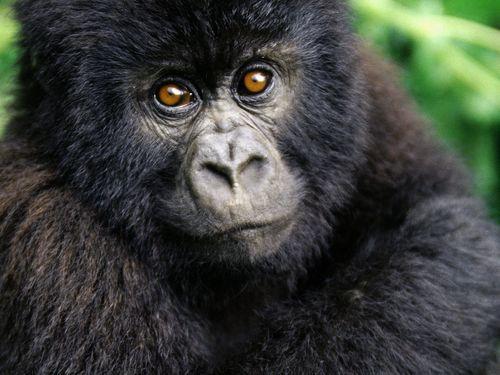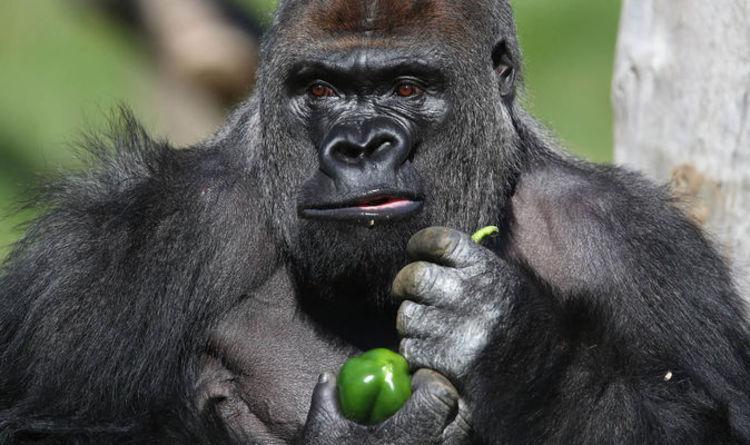The first image is the image on the left, the second image is the image on the right. Assess this claim about the two images: "An image shows a baby gorilla with an adult gorilla.". Correct or not? Answer yes or no. No. 